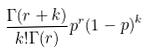<formula> <loc_0><loc_0><loc_500><loc_500>\frac { \Gamma ( r + k ) } { k ! \Gamma ( r ) } p ^ { r } ( 1 - p ) ^ { k }</formula> 